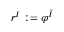Convert formula to latex. <formula><loc_0><loc_0><loc_500><loc_500>r ^ { I } \colon = \varphi ^ { \bar { I } }</formula> 